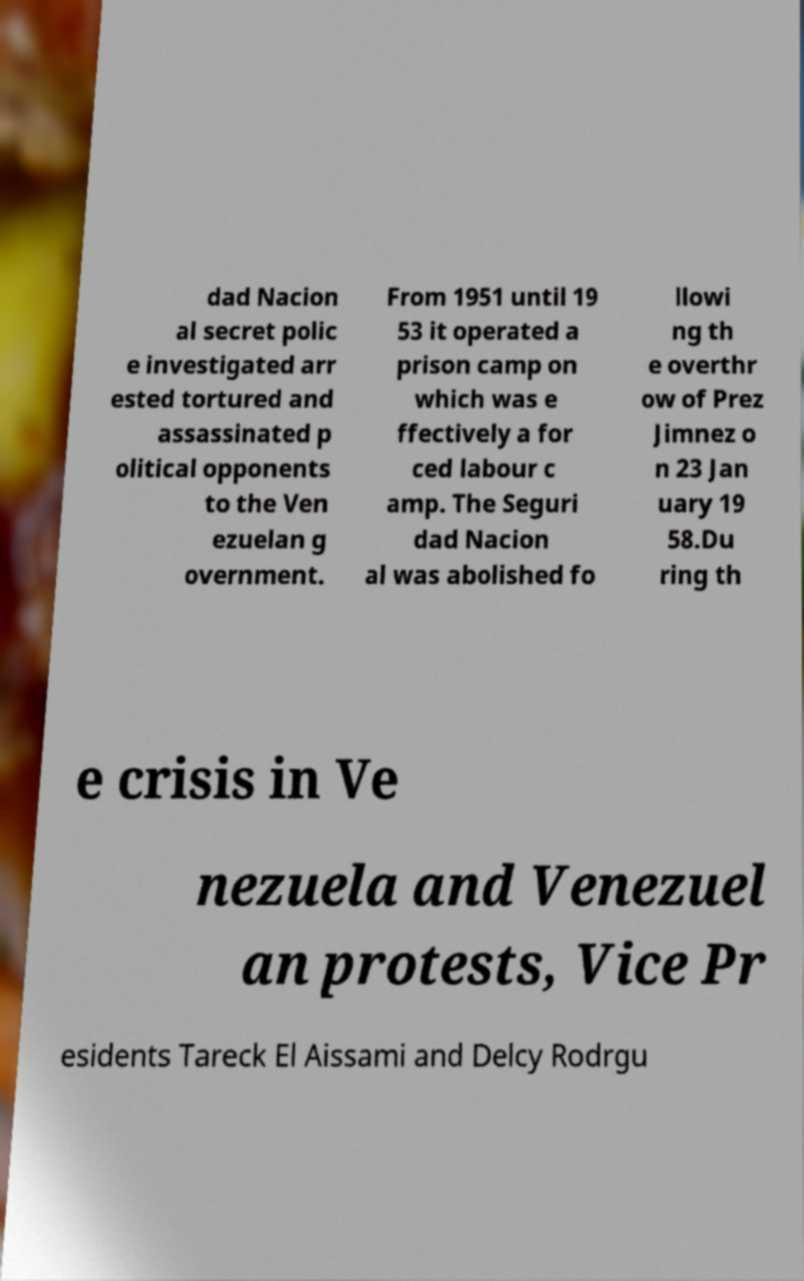For documentation purposes, I need the text within this image transcribed. Could you provide that? dad Nacion al secret polic e investigated arr ested tortured and assassinated p olitical opponents to the Ven ezuelan g overnment. From 1951 until 19 53 it operated a prison camp on which was e ffectively a for ced labour c amp. The Seguri dad Nacion al was abolished fo llowi ng th e overthr ow of Prez Jimnez o n 23 Jan uary 19 58.Du ring th e crisis in Ve nezuela and Venezuel an protests, Vice Pr esidents Tareck El Aissami and Delcy Rodrgu 